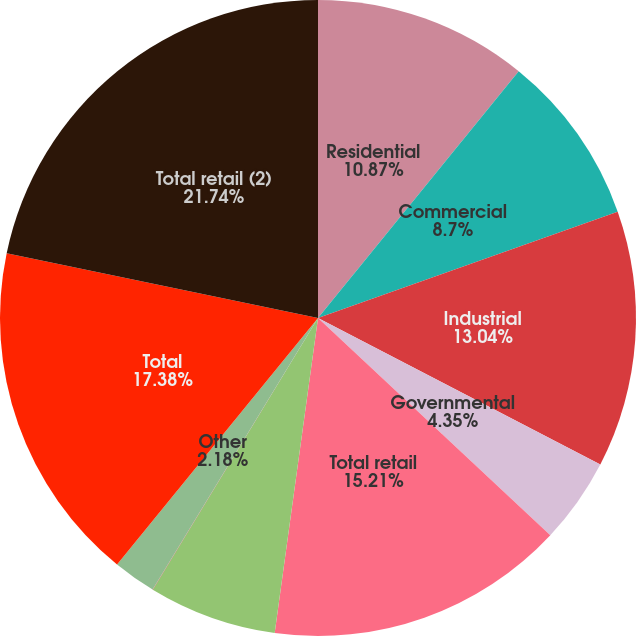Convert chart to OTSL. <chart><loc_0><loc_0><loc_500><loc_500><pie_chart><fcel>Residential<fcel>Commercial<fcel>Industrial<fcel>Governmental<fcel>Total retail<fcel>Associated companies<fcel>Non-associated companies<fcel>Other<fcel>Total<fcel>Total retail (2)<nl><fcel>10.87%<fcel>8.7%<fcel>13.04%<fcel>4.35%<fcel>15.21%<fcel>6.52%<fcel>0.01%<fcel>2.18%<fcel>17.38%<fcel>21.73%<nl></chart> 